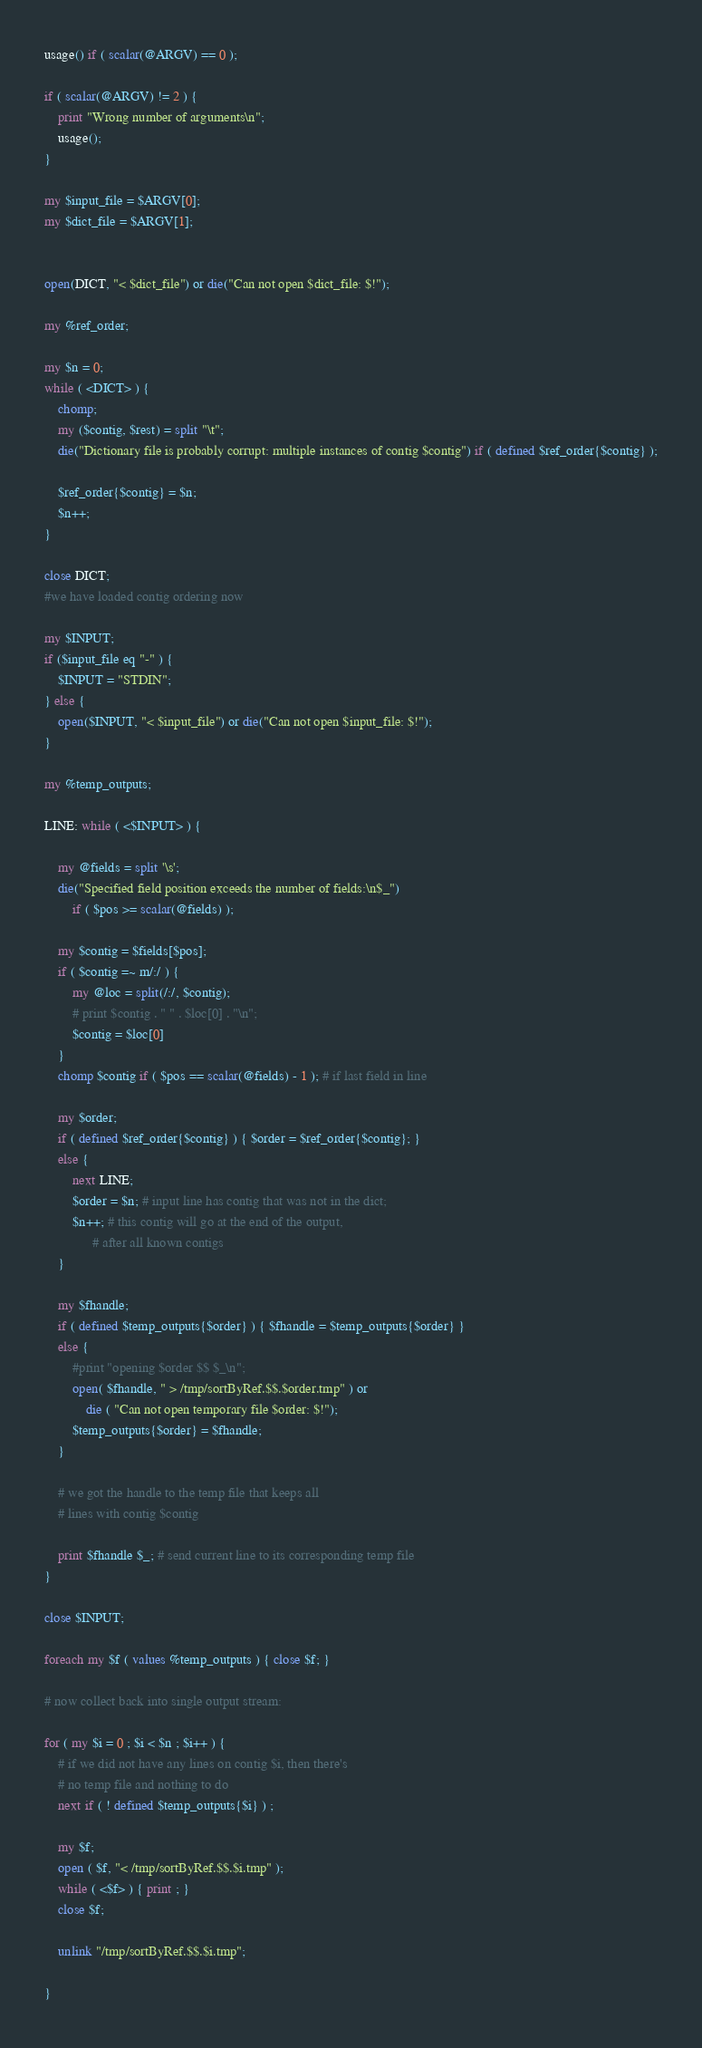<code> <loc_0><loc_0><loc_500><loc_500><_Perl_>
usage() if ( scalar(@ARGV) == 0 );

if ( scalar(@ARGV) != 2 ) {
    print "Wrong number of arguments\n";
    usage();
}

my $input_file = $ARGV[0];
my $dict_file = $ARGV[1];


open(DICT, "< $dict_file") or die("Can not open $dict_file: $!");

my %ref_order;

my $n = 0;
while ( <DICT> ) {
    chomp;
    my ($contig, $rest) = split "\t";
    die("Dictionary file is probably corrupt: multiple instances of contig $contig") if ( defined $ref_order{$contig} );

    $ref_order{$contig} = $n;
    $n++;
}

close DICT;
#we have loaded contig ordering now

my $INPUT;
if ($input_file eq "-" ) {
    $INPUT = "STDIN";
} else {
    open($INPUT, "< $input_file") or die("Can not open $input_file: $!");
}

my %temp_outputs;

LINE: while ( <$INPUT> ) {
    
    my @fields = split '\s';
    die("Specified field position exceeds the number of fields:\n$_") 
        if ( $pos >= scalar(@fields) );

    my $contig = $fields[$pos];
    if ( $contig =~ m/:/ ) {
        my @loc = split(/:/, $contig);
        # print $contig . " " . $loc[0] . "\n";
        $contig = $loc[0]
    }
    chomp $contig if ( $pos == scalar(@fields) - 1 ); # if last field in line

    my $order;
    if ( defined $ref_order{$contig} ) { $order = $ref_order{$contig}; }
    else {
    	next LINE;
        $order = $n; # input line has contig that was not in the dict; 
        $n++; # this contig will go at the end of the output, 
              # after all known contigs
    }

    my $fhandle;
    if ( defined $temp_outputs{$order} ) { $fhandle = $temp_outputs{$order} }
    else {
        #print "opening $order $$ $_\n";
        open( $fhandle, " > /tmp/sortByRef.$$.$order.tmp" ) or
            die ( "Can not open temporary file $order: $!");
        $temp_outputs{$order} = $fhandle;
    }

    # we got the handle to the temp file that keeps all 
    # lines with contig $contig

    print $fhandle $_; # send current line to its corresponding temp file
}

close $INPUT;

foreach my $f ( values %temp_outputs ) { close $f; }

# now collect back into single output stream:

for ( my $i = 0 ; $i < $n ; $i++ ) {
    # if we did not have any lines on contig $i, then there's 
    # no temp file and nothing to do
    next if ( ! defined $temp_outputs{$i} ) ; 

    my $f; 
    open ( $f, "< /tmp/sortByRef.$$.$i.tmp" );
    while ( <$f> ) { print ; }
    close $f;

    unlink "/tmp/sortByRef.$$.$i.tmp";

}
</code> 